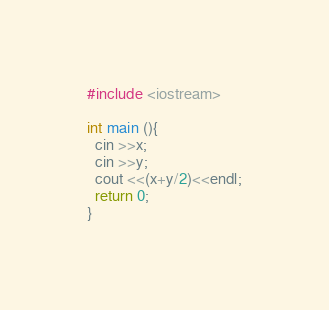Convert code to text. <code><loc_0><loc_0><loc_500><loc_500><_C++_>#include <iostream>

int main (){
  cin >>x;
  cin >>y;
  cout <<(x+y/2)<<endl;
  return 0;
}
</code> 